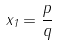<formula> <loc_0><loc_0><loc_500><loc_500>x _ { 1 } = \frac { p } { q }</formula> 